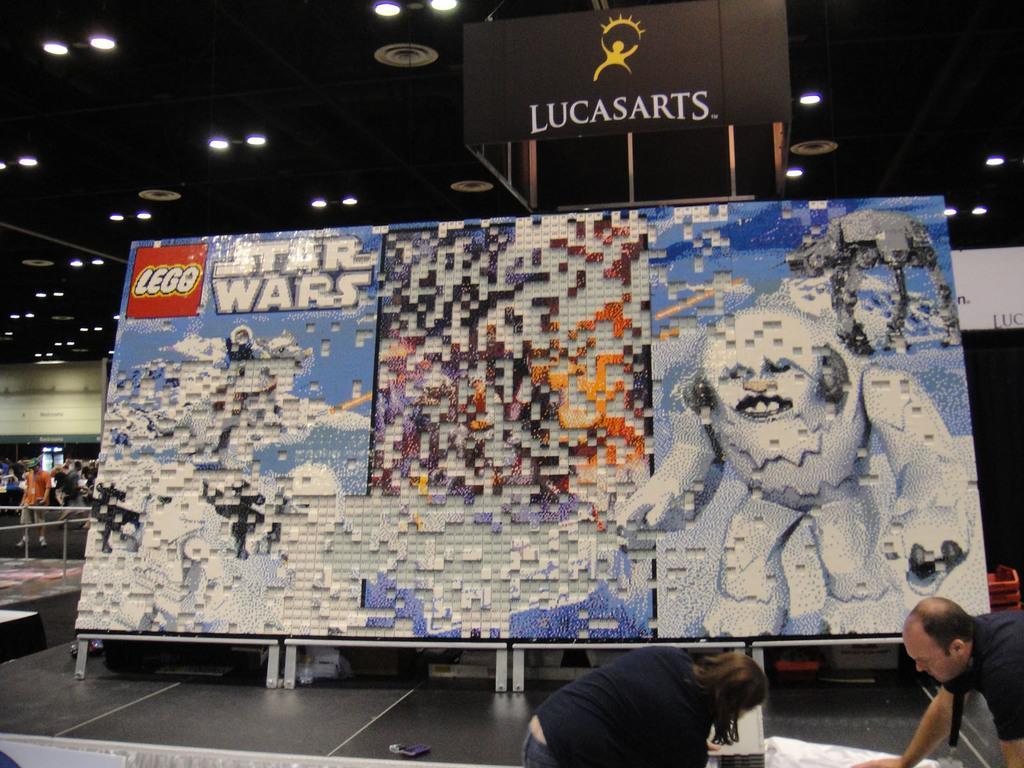Please provide a concise description of this image. In this image we can see a board with some Lego blocks and text on it which is placed on the surface. On the bottom of the image we can see a man and a woman standing. On the backside we can see a group of people, some metal poles, a wall and a roof with some ceiling lights. 